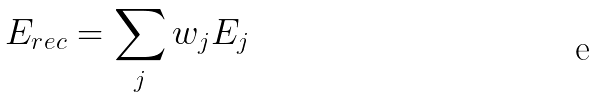Convert formula to latex. <formula><loc_0><loc_0><loc_500><loc_500>E _ { r e c } = \sum _ { j } w _ { j } E _ { j }</formula> 